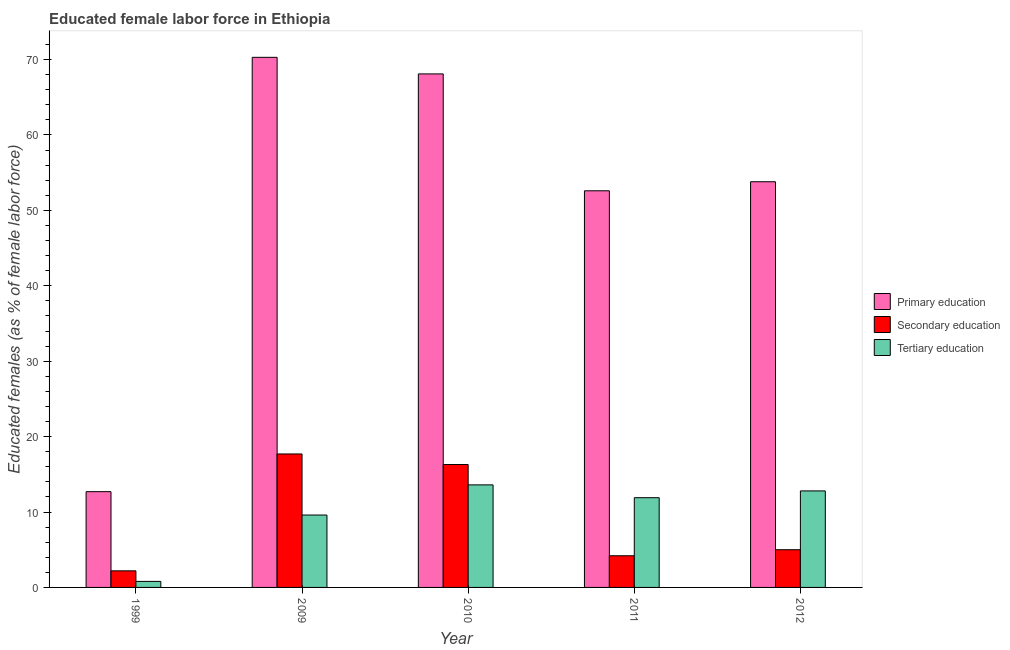How many different coloured bars are there?
Provide a succinct answer. 3. How many groups of bars are there?
Provide a short and direct response. 5. How many bars are there on the 4th tick from the left?
Your answer should be very brief. 3. What is the percentage of female labor force who received primary education in 2011?
Give a very brief answer. 52.6. Across all years, what is the maximum percentage of female labor force who received secondary education?
Provide a succinct answer. 17.7. Across all years, what is the minimum percentage of female labor force who received tertiary education?
Provide a short and direct response. 0.8. In which year was the percentage of female labor force who received tertiary education maximum?
Give a very brief answer. 2010. In which year was the percentage of female labor force who received secondary education minimum?
Give a very brief answer. 1999. What is the total percentage of female labor force who received secondary education in the graph?
Keep it short and to the point. 45.4. What is the difference between the percentage of female labor force who received primary education in 2010 and that in 2011?
Give a very brief answer. 15.5. What is the difference between the percentage of female labor force who received tertiary education in 2012 and the percentage of female labor force who received primary education in 2009?
Give a very brief answer. 3.2. What is the average percentage of female labor force who received primary education per year?
Offer a terse response. 51.5. In the year 2012, what is the difference between the percentage of female labor force who received secondary education and percentage of female labor force who received primary education?
Your answer should be very brief. 0. What is the ratio of the percentage of female labor force who received primary education in 1999 to that in 2009?
Offer a very short reply. 0.18. Is the difference between the percentage of female labor force who received secondary education in 1999 and 2011 greater than the difference between the percentage of female labor force who received tertiary education in 1999 and 2011?
Offer a terse response. No. What is the difference between the highest and the second highest percentage of female labor force who received secondary education?
Ensure brevity in your answer.  1.4. What is the difference between the highest and the lowest percentage of female labor force who received secondary education?
Keep it short and to the point. 15.5. What does the 2nd bar from the left in 1999 represents?
Ensure brevity in your answer.  Secondary education. What does the 2nd bar from the right in 2012 represents?
Keep it short and to the point. Secondary education. Is it the case that in every year, the sum of the percentage of female labor force who received primary education and percentage of female labor force who received secondary education is greater than the percentage of female labor force who received tertiary education?
Offer a terse response. Yes. What is the difference between two consecutive major ticks on the Y-axis?
Your answer should be very brief. 10. Are the values on the major ticks of Y-axis written in scientific E-notation?
Provide a succinct answer. No. How many legend labels are there?
Your answer should be very brief. 3. What is the title of the graph?
Provide a short and direct response. Educated female labor force in Ethiopia. What is the label or title of the Y-axis?
Your answer should be very brief. Educated females (as % of female labor force). What is the Educated females (as % of female labor force) of Primary education in 1999?
Give a very brief answer. 12.7. What is the Educated females (as % of female labor force) of Secondary education in 1999?
Give a very brief answer. 2.2. What is the Educated females (as % of female labor force) of Tertiary education in 1999?
Provide a succinct answer. 0.8. What is the Educated females (as % of female labor force) of Primary education in 2009?
Give a very brief answer. 70.3. What is the Educated females (as % of female labor force) of Secondary education in 2009?
Give a very brief answer. 17.7. What is the Educated females (as % of female labor force) in Tertiary education in 2009?
Your response must be concise. 9.6. What is the Educated females (as % of female labor force) of Primary education in 2010?
Your answer should be compact. 68.1. What is the Educated females (as % of female labor force) of Secondary education in 2010?
Your answer should be very brief. 16.3. What is the Educated females (as % of female labor force) in Tertiary education in 2010?
Give a very brief answer. 13.6. What is the Educated females (as % of female labor force) in Primary education in 2011?
Your response must be concise. 52.6. What is the Educated females (as % of female labor force) in Secondary education in 2011?
Offer a very short reply. 4.2. What is the Educated females (as % of female labor force) in Tertiary education in 2011?
Make the answer very short. 11.9. What is the Educated females (as % of female labor force) in Primary education in 2012?
Give a very brief answer. 53.8. What is the Educated females (as % of female labor force) of Secondary education in 2012?
Offer a terse response. 5. What is the Educated females (as % of female labor force) of Tertiary education in 2012?
Offer a very short reply. 12.8. Across all years, what is the maximum Educated females (as % of female labor force) of Primary education?
Give a very brief answer. 70.3. Across all years, what is the maximum Educated females (as % of female labor force) in Secondary education?
Your answer should be very brief. 17.7. Across all years, what is the maximum Educated females (as % of female labor force) of Tertiary education?
Make the answer very short. 13.6. Across all years, what is the minimum Educated females (as % of female labor force) in Primary education?
Ensure brevity in your answer.  12.7. Across all years, what is the minimum Educated females (as % of female labor force) in Secondary education?
Offer a very short reply. 2.2. Across all years, what is the minimum Educated females (as % of female labor force) of Tertiary education?
Make the answer very short. 0.8. What is the total Educated females (as % of female labor force) of Primary education in the graph?
Provide a short and direct response. 257.5. What is the total Educated females (as % of female labor force) of Secondary education in the graph?
Your answer should be very brief. 45.4. What is the total Educated females (as % of female labor force) of Tertiary education in the graph?
Keep it short and to the point. 48.7. What is the difference between the Educated females (as % of female labor force) in Primary education in 1999 and that in 2009?
Give a very brief answer. -57.6. What is the difference between the Educated females (as % of female labor force) in Secondary education in 1999 and that in 2009?
Give a very brief answer. -15.5. What is the difference between the Educated females (as % of female labor force) in Tertiary education in 1999 and that in 2009?
Your answer should be very brief. -8.8. What is the difference between the Educated females (as % of female labor force) of Primary education in 1999 and that in 2010?
Your answer should be compact. -55.4. What is the difference between the Educated females (as % of female labor force) in Secondary education in 1999 and that in 2010?
Provide a short and direct response. -14.1. What is the difference between the Educated females (as % of female labor force) in Primary education in 1999 and that in 2011?
Provide a short and direct response. -39.9. What is the difference between the Educated females (as % of female labor force) of Secondary education in 1999 and that in 2011?
Your answer should be very brief. -2. What is the difference between the Educated females (as % of female labor force) in Tertiary education in 1999 and that in 2011?
Provide a short and direct response. -11.1. What is the difference between the Educated females (as % of female labor force) in Primary education in 1999 and that in 2012?
Your answer should be compact. -41.1. What is the difference between the Educated females (as % of female labor force) in Tertiary education in 1999 and that in 2012?
Provide a short and direct response. -12. What is the difference between the Educated females (as % of female labor force) of Secondary education in 2009 and that in 2010?
Ensure brevity in your answer.  1.4. What is the difference between the Educated females (as % of female labor force) in Tertiary education in 2009 and that in 2010?
Offer a very short reply. -4. What is the difference between the Educated females (as % of female labor force) of Primary education in 2009 and that in 2012?
Make the answer very short. 16.5. What is the difference between the Educated females (as % of female labor force) in Tertiary education in 2010 and that in 2011?
Your response must be concise. 1.7. What is the difference between the Educated females (as % of female labor force) of Tertiary education in 2010 and that in 2012?
Offer a terse response. 0.8. What is the difference between the Educated females (as % of female labor force) in Tertiary education in 2011 and that in 2012?
Your response must be concise. -0.9. What is the difference between the Educated females (as % of female labor force) of Primary education in 1999 and the Educated females (as % of female labor force) of Secondary education in 2011?
Keep it short and to the point. 8.5. What is the difference between the Educated females (as % of female labor force) in Primary education in 1999 and the Educated females (as % of female labor force) in Tertiary education in 2011?
Your response must be concise. 0.8. What is the difference between the Educated females (as % of female labor force) of Primary education in 1999 and the Educated females (as % of female labor force) of Secondary education in 2012?
Ensure brevity in your answer.  7.7. What is the difference between the Educated females (as % of female labor force) of Primary education in 1999 and the Educated females (as % of female labor force) of Tertiary education in 2012?
Offer a terse response. -0.1. What is the difference between the Educated females (as % of female labor force) of Secondary education in 1999 and the Educated females (as % of female labor force) of Tertiary education in 2012?
Make the answer very short. -10.6. What is the difference between the Educated females (as % of female labor force) in Primary education in 2009 and the Educated females (as % of female labor force) in Tertiary education in 2010?
Ensure brevity in your answer.  56.7. What is the difference between the Educated females (as % of female labor force) of Primary education in 2009 and the Educated females (as % of female labor force) of Secondary education in 2011?
Offer a terse response. 66.1. What is the difference between the Educated females (as % of female labor force) of Primary education in 2009 and the Educated females (as % of female labor force) of Tertiary education in 2011?
Offer a terse response. 58.4. What is the difference between the Educated females (as % of female labor force) of Primary education in 2009 and the Educated females (as % of female labor force) of Secondary education in 2012?
Ensure brevity in your answer.  65.3. What is the difference between the Educated females (as % of female labor force) in Primary education in 2009 and the Educated females (as % of female labor force) in Tertiary education in 2012?
Your answer should be compact. 57.5. What is the difference between the Educated females (as % of female labor force) in Secondary education in 2009 and the Educated females (as % of female labor force) in Tertiary education in 2012?
Your answer should be compact. 4.9. What is the difference between the Educated females (as % of female labor force) of Primary education in 2010 and the Educated females (as % of female labor force) of Secondary education in 2011?
Offer a very short reply. 63.9. What is the difference between the Educated females (as % of female labor force) in Primary education in 2010 and the Educated females (as % of female labor force) in Tertiary education in 2011?
Provide a short and direct response. 56.2. What is the difference between the Educated females (as % of female labor force) of Primary education in 2010 and the Educated females (as % of female labor force) of Secondary education in 2012?
Offer a very short reply. 63.1. What is the difference between the Educated females (as % of female labor force) in Primary education in 2010 and the Educated females (as % of female labor force) in Tertiary education in 2012?
Your answer should be very brief. 55.3. What is the difference between the Educated females (as % of female labor force) in Secondary education in 2010 and the Educated females (as % of female labor force) in Tertiary education in 2012?
Your answer should be compact. 3.5. What is the difference between the Educated females (as % of female labor force) in Primary education in 2011 and the Educated females (as % of female labor force) in Secondary education in 2012?
Keep it short and to the point. 47.6. What is the difference between the Educated females (as % of female labor force) in Primary education in 2011 and the Educated females (as % of female labor force) in Tertiary education in 2012?
Keep it short and to the point. 39.8. What is the average Educated females (as % of female labor force) in Primary education per year?
Make the answer very short. 51.5. What is the average Educated females (as % of female labor force) of Secondary education per year?
Give a very brief answer. 9.08. What is the average Educated females (as % of female labor force) of Tertiary education per year?
Provide a succinct answer. 9.74. In the year 1999, what is the difference between the Educated females (as % of female labor force) in Primary education and Educated females (as % of female labor force) in Secondary education?
Offer a terse response. 10.5. In the year 1999, what is the difference between the Educated females (as % of female labor force) of Primary education and Educated females (as % of female labor force) of Tertiary education?
Offer a terse response. 11.9. In the year 2009, what is the difference between the Educated females (as % of female labor force) in Primary education and Educated females (as % of female labor force) in Secondary education?
Ensure brevity in your answer.  52.6. In the year 2009, what is the difference between the Educated females (as % of female labor force) in Primary education and Educated females (as % of female labor force) in Tertiary education?
Make the answer very short. 60.7. In the year 2009, what is the difference between the Educated females (as % of female labor force) of Secondary education and Educated females (as % of female labor force) of Tertiary education?
Your response must be concise. 8.1. In the year 2010, what is the difference between the Educated females (as % of female labor force) in Primary education and Educated females (as % of female labor force) in Secondary education?
Offer a very short reply. 51.8. In the year 2010, what is the difference between the Educated females (as % of female labor force) of Primary education and Educated females (as % of female labor force) of Tertiary education?
Provide a short and direct response. 54.5. In the year 2010, what is the difference between the Educated females (as % of female labor force) in Secondary education and Educated females (as % of female labor force) in Tertiary education?
Provide a succinct answer. 2.7. In the year 2011, what is the difference between the Educated females (as % of female labor force) of Primary education and Educated females (as % of female labor force) of Secondary education?
Keep it short and to the point. 48.4. In the year 2011, what is the difference between the Educated females (as % of female labor force) in Primary education and Educated females (as % of female labor force) in Tertiary education?
Give a very brief answer. 40.7. In the year 2011, what is the difference between the Educated females (as % of female labor force) of Secondary education and Educated females (as % of female labor force) of Tertiary education?
Give a very brief answer. -7.7. In the year 2012, what is the difference between the Educated females (as % of female labor force) of Primary education and Educated females (as % of female labor force) of Secondary education?
Provide a succinct answer. 48.8. In the year 2012, what is the difference between the Educated females (as % of female labor force) in Primary education and Educated females (as % of female labor force) in Tertiary education?
Keep it short and to the point. 41. What is the ratio of the Educated females (as % of female labor force) in Primary education in 1999 to that in 2009?
Offer a terse response. 0.18. What is the ratio of the Educated females (as % of female labor force) in Secondary education in 1999 to that in 2009?
Provide a succinct answer. 0.12. What is the ratio of the Educated females (as % of female labor force) in Tertiary education in 1999 to that in 2009?
Make the answer very short. 0.08. What is the ratio of the Educated females (as % of female labor force) of Primary education in 1999 to that in 2010?
Provide a short and direct response. 0.19. What is the ratio of the Educated females (as % of female labor force) of Secondary education in 1999 to that in 2010?
Make the answer very short. 0.14. What is the ratio of the Educated females (as % of female labor force) in Tertiary education in 1999 to that in 2010?
Your response must be concise. 0.06. What is the ratio of the Educated females (as % of female labor force) of Primary education in 1999 to that in 2011?
Offer a terse response. 0.24. What is the ratio of the Educated females (as % of female labor force) of Secondary education in 1999 to that in 2011?
Your answer should be compact. 0.52. What is the ratio of the Educated females (as % of female labor force) of Tertiary education in 1999 to that in 2011?
Give a very brief answer. 0.07. What is the ratio of the Educated females (as % of female labor force) in Primary education in 1999 to that in 2012?
Keep it short and to the point. 0.24. What is the ratio of the Educated females (as % of female labor force) in Secondary education in 1999 to that in 2012?
Provide a succinct answer. 0.44. What is the ratio of the Educated females (as % of female labor force) in Tertiary education in 1999 to that in 2012?
Give a very brief answer. 0.06. What is the ratio of the Educated females (as % of female labor force) of Primary education in 2009 to that in 2010?
Offer a terse response. 1.03. What is the ratio of the Educated females (as % of female labor force) in Secondary education in 2009 to that in 2010?
Keep it short and to the point. 1.09. What is the ratio of the Educated females (as % of female labor force) in Tertiary education in 2009 to that in 2010?
Your answer should be compact. 0.71. What is the ratio of the Educated females (as % of female labor force) in Primary education in 2009 to that in 2011?
Provide a short and direct response. 1.34. What is the ratio of the Educated females (as % of female labor force) of Secondary education in 2009 to that in 2011?
Ensure brevity in your answer.  4.21. What is the ratio of the Educated females (as % of female labor force) in Tertiary education in 2009 to that in 2011?
Provide a succinct answer. 0.81. What is the ratio of the Educated females (as % of female labor force) of Primary education in 2009 to that in 2012?
Make the answer very short. 1.31. What is the ratio of the Educated females (as % of female labor force) of Secondary education in 2009 to that in 2012?
Offer a terse response. 3.54. What is the ratio of the Educated females (as % of female labor force) in Tertiary education in 2009 to that in 2012?
Provide a short and direct response. 0.75. What is the ratio of the Educated females (as % of female labor force) of Primary education in 2010 to that in 2011?
Your response must be concise. 1.29. What is the ratio of the Educated females (as % of female labor force) in Secondary education in 2010 to that in 2011?
Provide a short and direct response. 3.88. What is the ratio of the Educated females (as % of female labor force) of Primary education in 2010 to that in 2012?
Offer a terse response. 1.27. What is the ratio of the Educated females (as % of female labor force) of Secondary education in 2010 to that in 2012?
Provide a short and direct response. 3.26. What is the ratio of the Educated females (as % of female labor force) in Tertiary education in 2010 to that in 2012?
Your answer should be very brief. 1.06. What is the ratio of the Educated females (as % of female labor force) in Primary education in 2011 to that in 2012?
Keep it short and to the point. 0.98. What is the ratio of the Educated females (as % of female labor force) in Secondary education in 2011 to that in 2012?
Make the answer very short. 0.84. What is the ratio of the Educated females (as % of female labor force) in Tertiary education in 2011 to that in 2012?
Give a very brief answer. 0.93. What is the difference between the highest and the second highest Educated females (as % of female labor force) in Secondary education?
Your answer should be very brief. 1.4. What is the difference between the highest and the second highest Educated females (as % of female labor force) in Tertiary education?
Your response must be concise. 0.8. What is the difference between the highest and the lowest Educated females (as % of female labor force) in Primary education?
Make the answer very short. 57.6. 